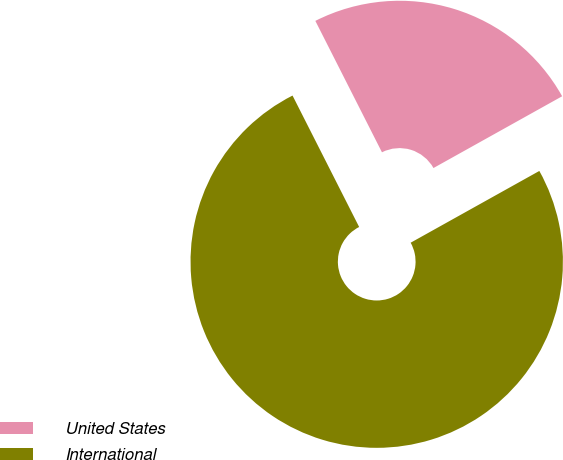Convert chart. <chart><loc_0><loc_0><loc_500><loc_500><pie_chart><fcel>United States<fcel>International<nl><fcel>24.37%<fcel>75.63%<nl></chart> 